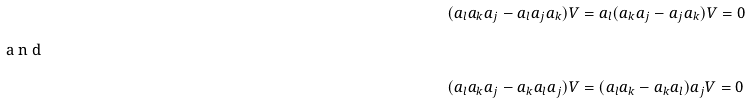Convert formula to latex. <formula><loc_0><loc_0><loc_500><loc_500>( a _ { l } a _ { k } a _ { j } - a _ { l } a _ { j } a _ { k } ) V & = a _ { l } ( a _ { k } a _ { j } - a _ { j } a _ { k } ) V = 0 \intertext { a n d } ( a _ { l } a _ { k } a _ { j } - a _ { k } a _ { l } a _ { j } ) V & = ( a _ { l } a _ { k } - a _ { k } a _ { l } ) a _ { j } V = 0</formula> 